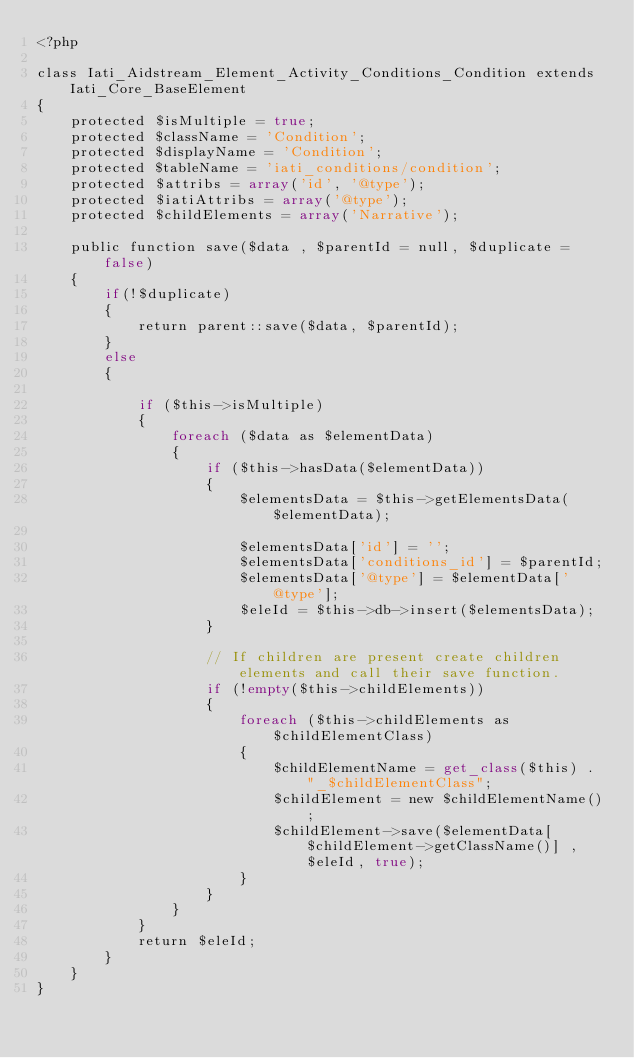Convert code to text. <code><loc_0><loc_0><loc_500><loc_500><_PHP_><?php

class Iati_Aidstream_Element_Activity_Conditions_Condition extends Iati_Core_BaseElement
{
    protected $isMultiple = true;
    protected $className = 'Condition';
    protected $displayName = 'Condition';
    protected $tableName = 'iati_conditions/condition';
    protected $attribs = array('id', '@type');
    protected $iatiAttribs = array('@type');
    protected $childElements = array('Narrative');

    public function save($data , $parentId = null, $duplicate = false)
    {
        if(!$duplicate)
        {
            return parent::save($data, $parentId);
        }
        else
        {

            if ($this->isMultiple)
            {
                foreach ($data as $elementData)
                {
                    if ($this->hasData($elementData))
                    {
                        $elementsData = $this->getElementsData($elementData);

                        $elementsData['id'] = '';
                        $elementsData['conditions_id'] = $parentId;
                        $elementsData['@type'] = $elementData['@type'];
                        $eleId = $this->db->insert($elementsData);
                    }

                    // If children are present create children elements and call their save function.
                    if (!empty($this->childElements))
                    {
                        foreach ($this->childElements as $childElementClass)
                        {
                            $childElementName = get_class($this) . "_$childElementClass";
                            $childElement = new $childElementName();
                            $childElement->save($elementData[$childElement->getClassName()] , $eleId, true);
                        }
                    }
                }
            }
            return $eleId;
        }
    }
}</code> 